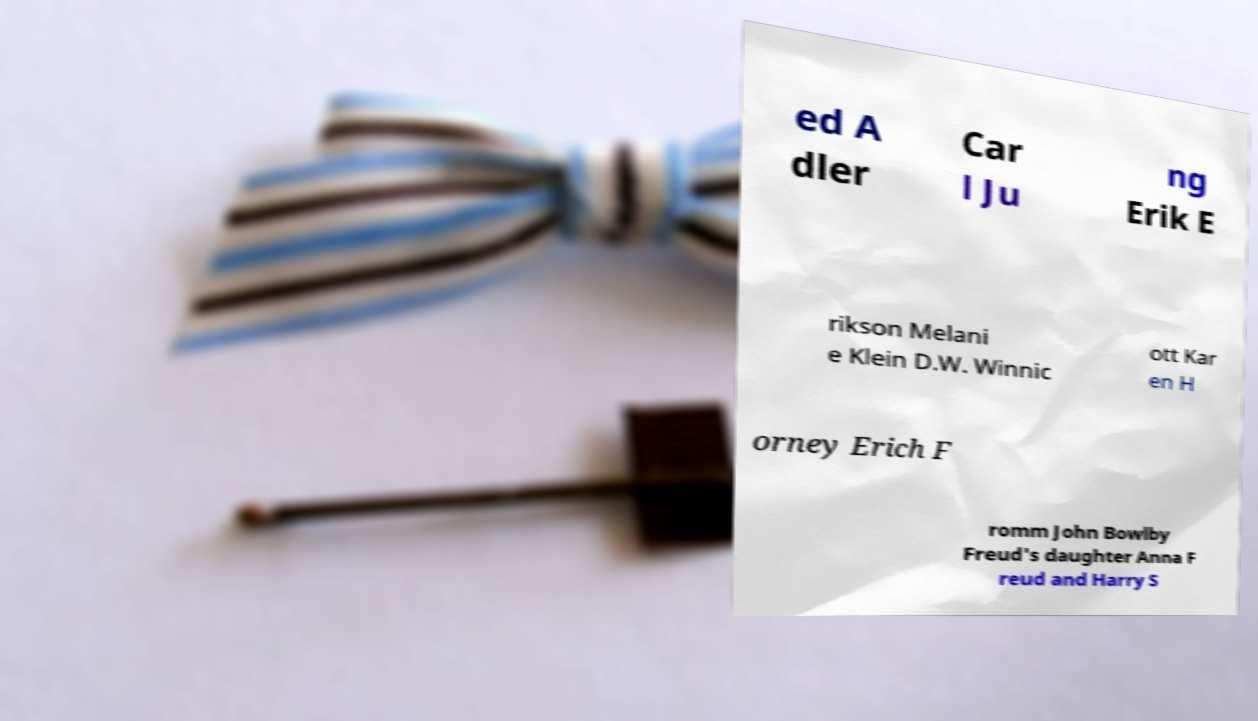Please read and relay the text visible in this image. What does it say? ed A dler Car l Ju ng Erik E rikson Melani e Klein D.W. Winnic ott Kar en H orney Erich F romm John Bowlby Freud's daughter Anna F reud and Harry S 